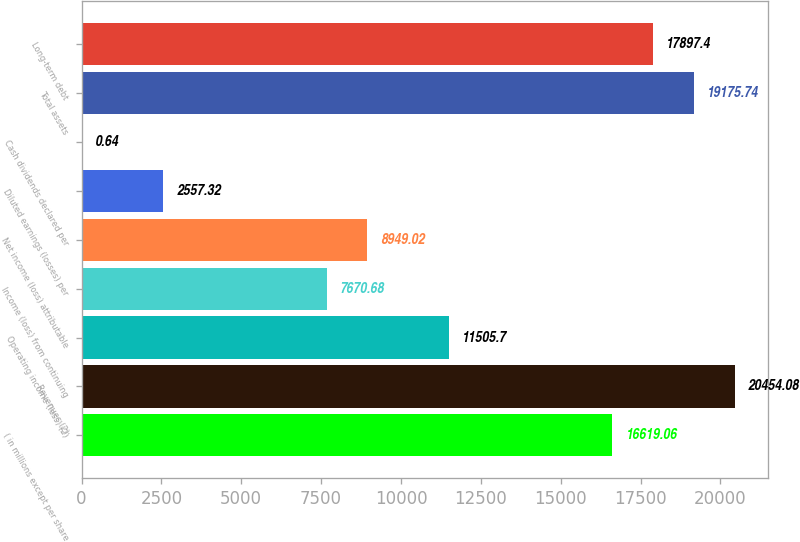Convert chart. <chart><loc_0><loc_0><loc_500><loc_500><bar_chart><fcel>( in millions except per share<fcel>Revenues (2)<fcel>Operating income (loss) (2)<fcel>Income (loss) from continuing<fcel>Net income (loss) attributable<fcel>Diluted earnings (losses) per<fcel>Cash dividends declared per<fcel>Total assets<fcel>Long-term debt<nl><fcel>16619.1<fcel>20454.1<fcel>11505.7<fcel>7670.68<fcel>8949.02<fcel>2557.32<fcel>0.64<fcel>19175.7<fcel>17897.4<nl></chart> 